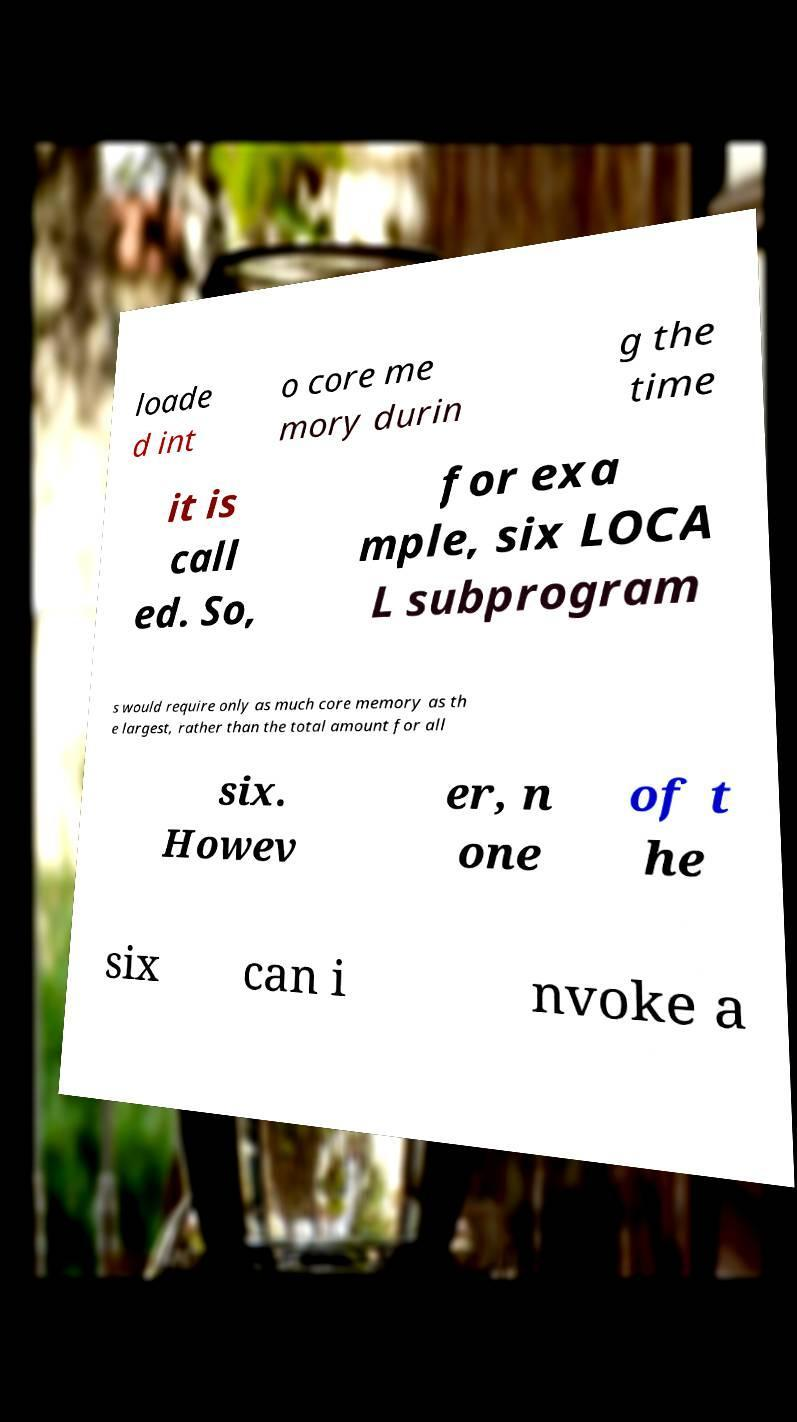Could you extract and type out the text from this image? loade d int o core me mory durin g the time it is call ed. So, for exa mple, six LOCA L subprogram s would require only as much core memory as th e largest, rather than the total amount for all six. Howev er, n one of t he six can i nvoke a 